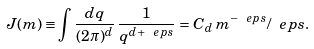<formula> <loc_0><loc_0><loc_500><loc_500>J ( m ) \equiv \int \frac { d { q } } { ( 2 \pi ) ^ { d } } \, \frac { 1 } { q ^ { d + \ e p s } } = C _ { d } \, m ^ { - \ e p s } / \ e p s .</formula> 